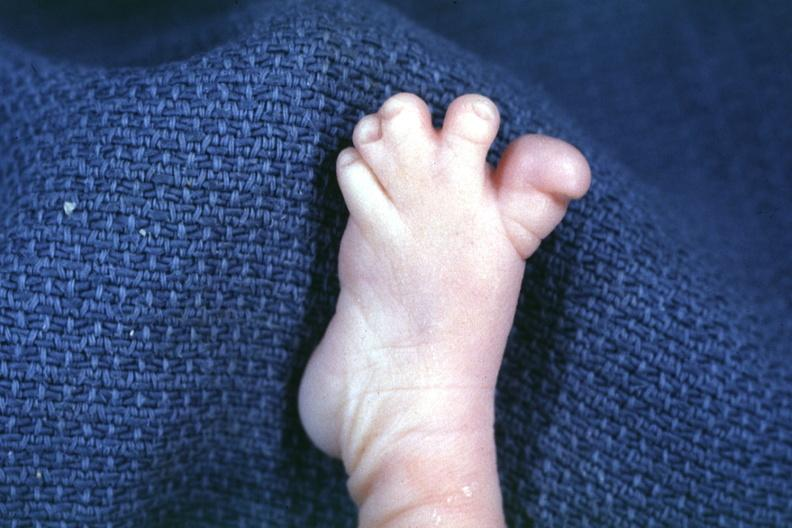what is present?
Answer the question using a single word or phrase. Syndactyly 